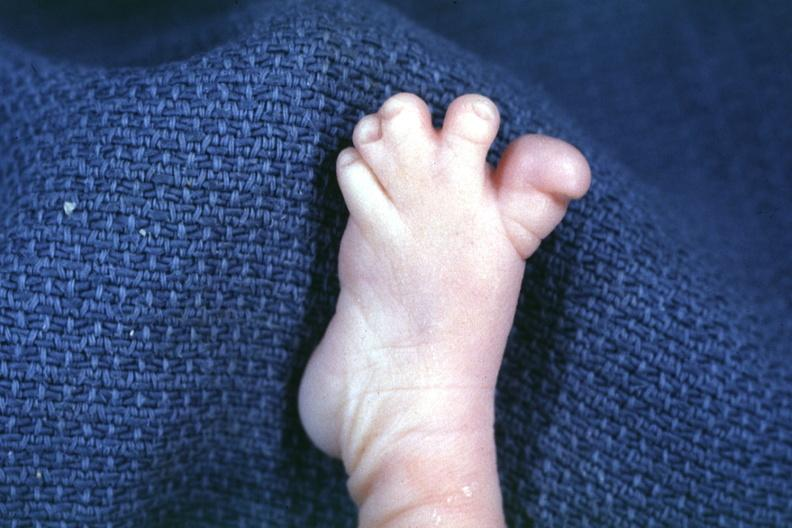what is present?
Answer the question using a single word or phrase. Syndactyly 